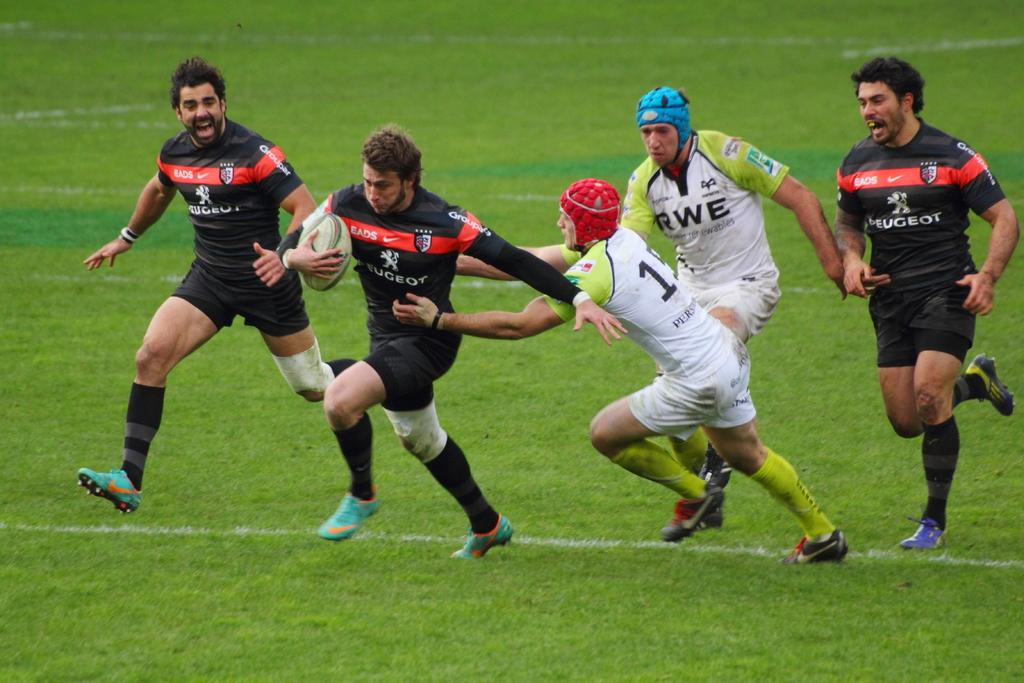What are the people in the image doing? The people in the image are playing a game on the ground. What object is being used in the game? One player is holding a ball in his hand. Can you describe the surface where the game is being played? The game is being played on the ground. What type of wool is being used to create a fire in the image? There is no wool or fire present in the image. Where is the shelf located in the image? There is no shelf present in the image. 